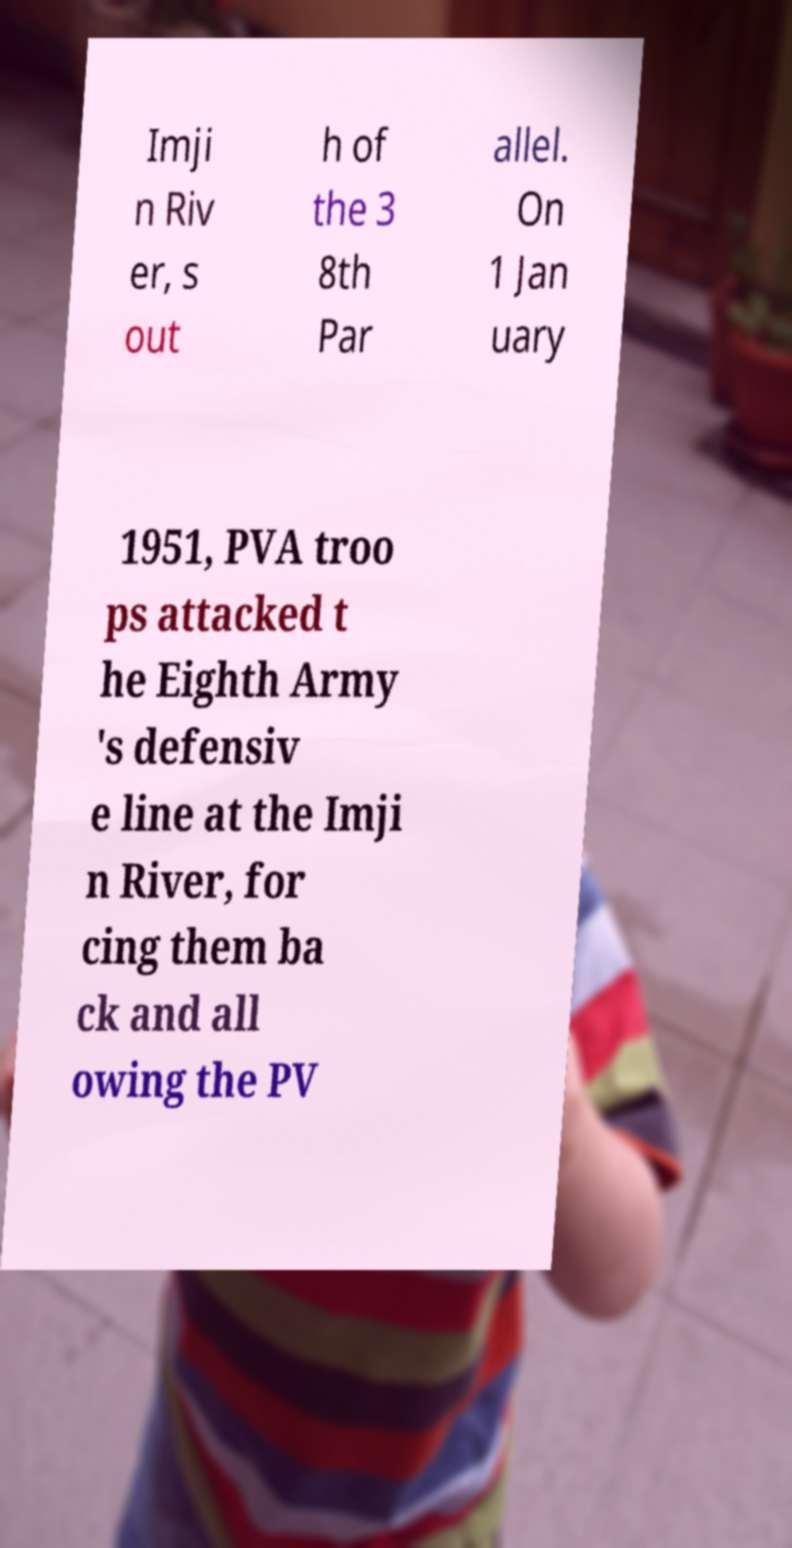Please identify and transcribe the text found in this image. Imji n Riv er, s out h of the 3 8th Par allel. On 1 Jan uary 1951, PVA troo ps attacked t he Eighth Army 's defensiv e line at the Imji n River, for cing them ba ck and all owing the PV 